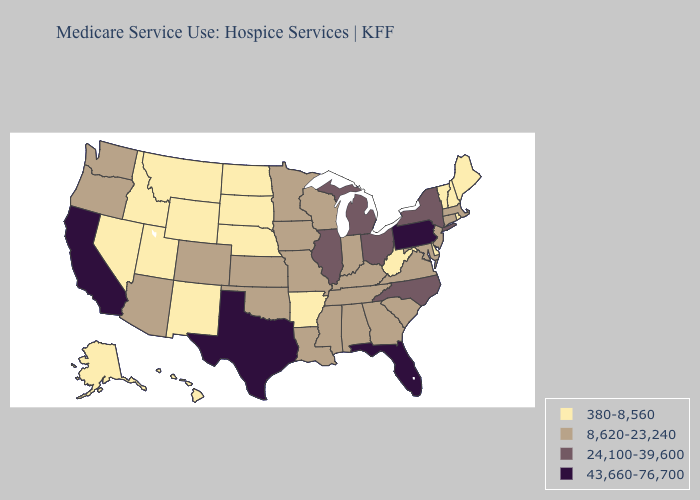What is the highest value in the South ?
Quick response, please. 43,660-76,700. What is the highest value in states that border New Jersey?
Write a very short answer. 43,660-76,700. Does Kentucky have the lowest value in the USA?
Concise answer only. No. Does the first symbol in the legend represent the smallest category?
Concise answer only. Yes. Does Colorado have the lowest value in the West?
Quick response, please. No. Among the states that border North Dakota , does Minnesota have the highest value?
Quick response, please. Yes. Which states have the lowest value in the USA?
Write a very short answer. Alaska, Arkansas, Delaware, Hawaii, Idaho, Maine, Montana, Nebraska, Nevada, New Hampshire, New Mexico, North Dakota, Rhode Island, South Dakota, Utah, Vermont, West Virginia, Wyoming. What is the value of Wisconsin?
Keep it brief. 8,620-23,240. What is the value of Virginia?
Answer briefly. 8,620-23,240. Does Nebraska have the lowest value in the MidWest?
Quick response, please. Yes. Name the states that have a value in the range 24,100-39,600?
Write a very short answer. Illinois, Michigan, New York, North Carolina, Ohio. Name the states that have a value in the range 8,620-23,240?
Give a very brief answer. Alabama, Arizona, Colorado, Connecticut, Georgia, Indiana, Iowa, Kansas, Kentucky, Louisiana, Maryland, Massachusetts, Minnesota, Mississippi, Missouri, New Jersey, Oklahoma, Oregon, South Carolina, Tennessee, Virginia, Washington, Wisconsin. Does Texas have the lowest value in the USA?
Concise answer only. No. Which states have the lowest value in the USA?
Answer briefly. Alaska, Arkansas, Delaware, Hawaii, Idaho, Maine, Montana, Nebraska, Nevada, New Hampshire, New Mexico, North Dakota, Rhode Island, South Dakota, Utah, Vermont, West Virginia, Wyoming. Does South Carolina have the highest value in the USA?
Write a very short answer. No. 